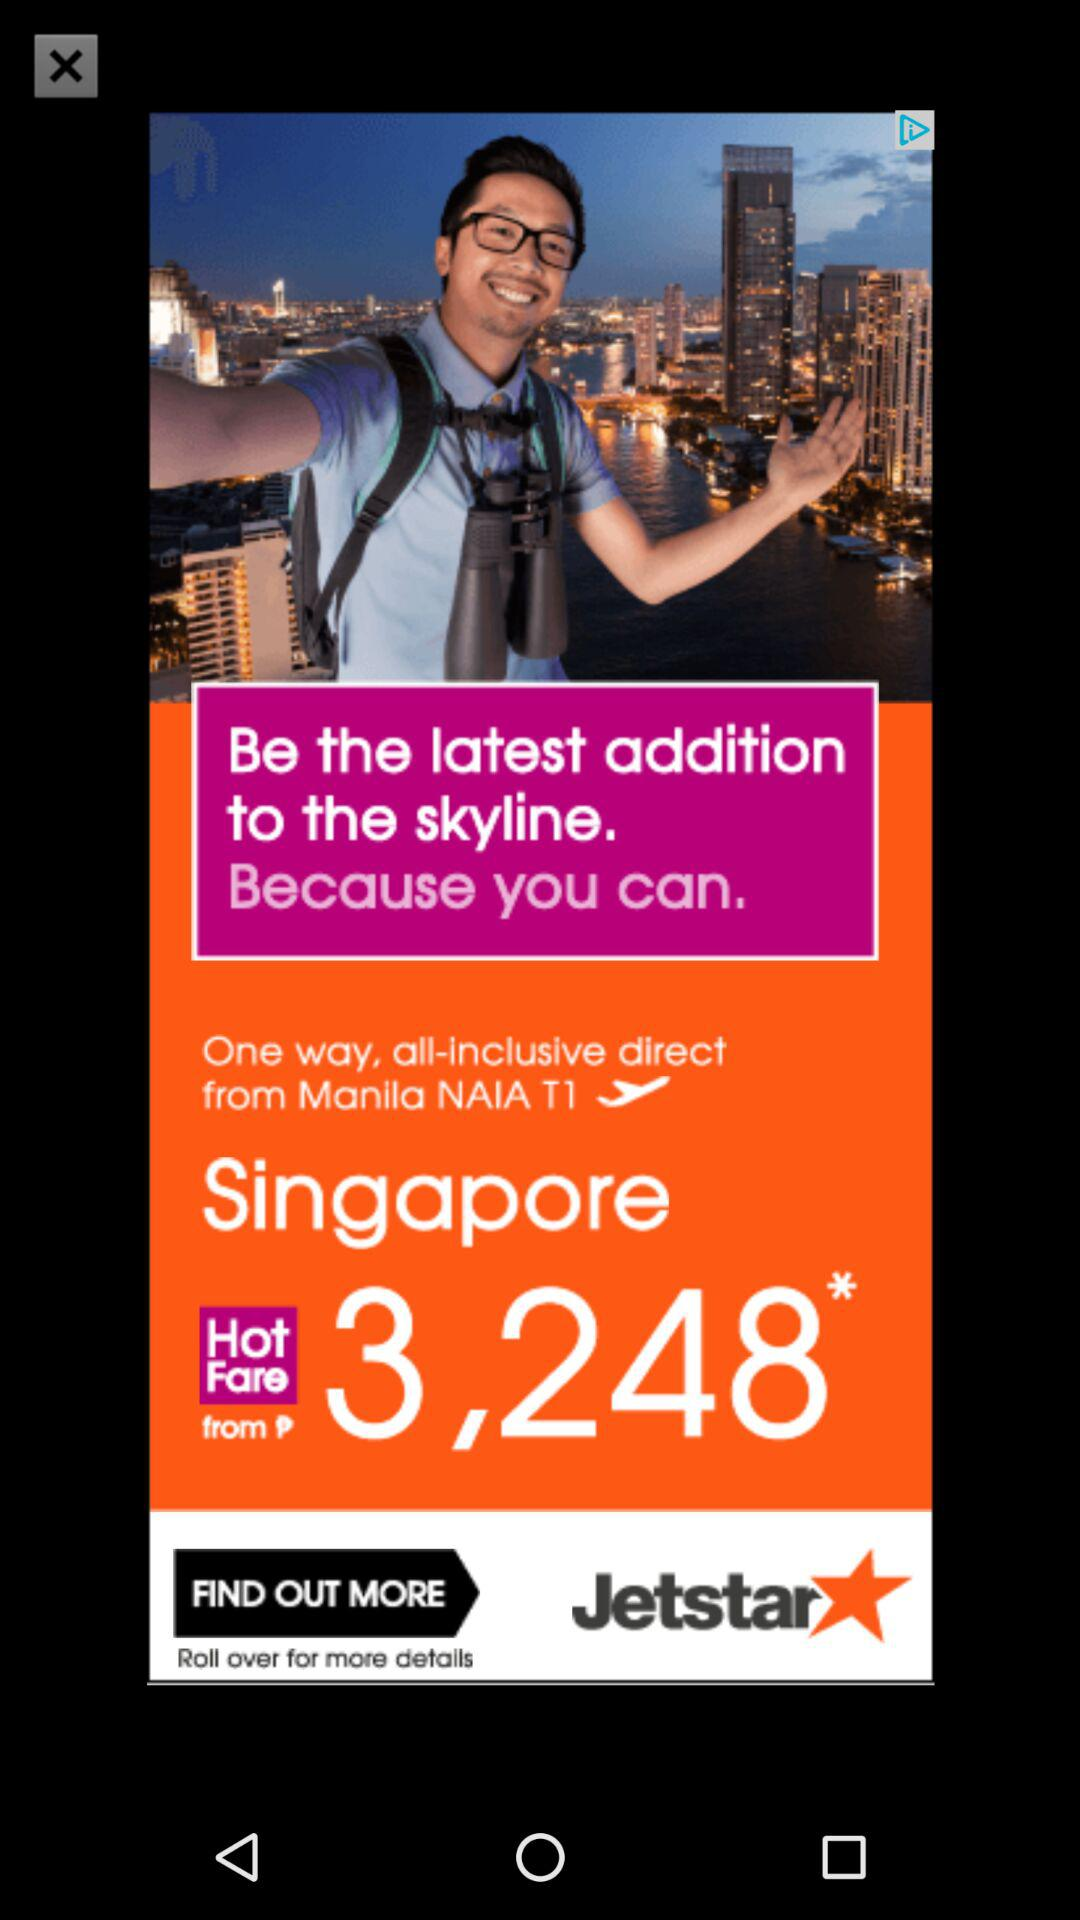What is the name of the application? The name of the application is "Jetstar". 